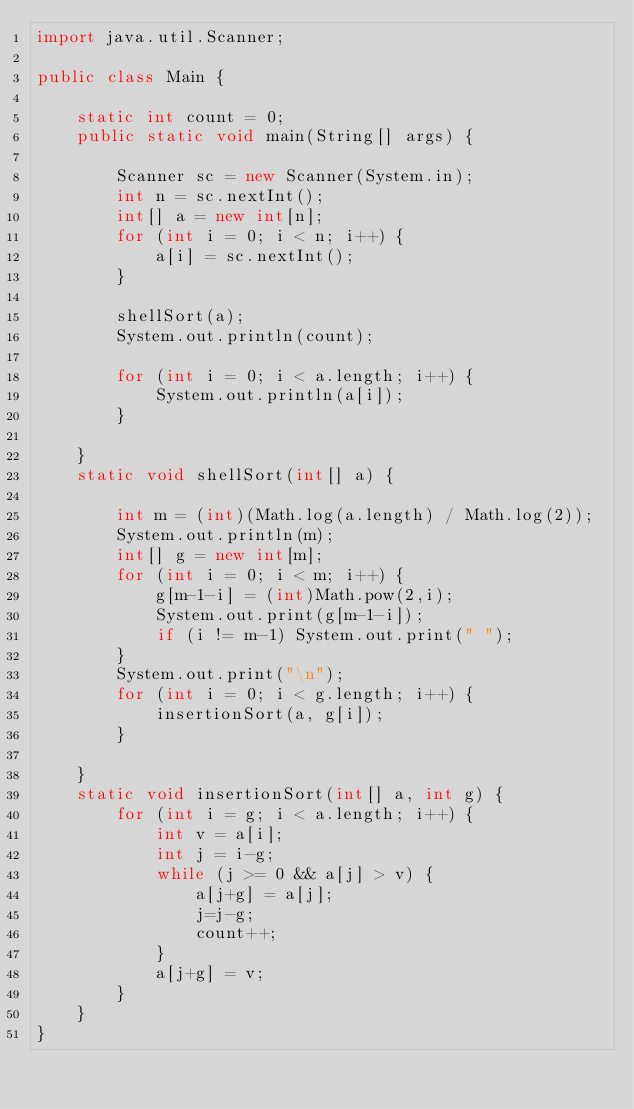<code> <loc_0><loc_0><loc_500><loc_500><_Java_>import java.util.Scanner;

public class Main {

	static int count = 0;
	public static void main(String[] args) {

		Scanner sc = new Scanner(System.in);
		int n = sc.nextInt();
		int[] a = new int[n];
		for (int i = 0; i < n; i++) {
			a[i] = sc.nextInt();
		}

		shellSort(a);
		System.out.println(count);

		for (int i = 0; i < a.length; i++) {
			System.out.println(a[i]);
		}

	}
	static void shellSort(int[] a) {

		int m = (int)(Math.log(a.length) / Math.log(2));
		System.out.println(m);
		int[] g = new int[m];
		for (int i = 0; i < m; i++) {
			g[m-1-i] = (int)Math.pow(2,i);
			System.out.print(g[m-1-i]);
			if (i != m-1) System.out.print(" ");
		}
		System.out.print("\n");
		for (int i = 0; i < g.length; i++) {
			insertionSort(a, g[i]);
		}

	}
	static void insertionSort(int[] a, int g) {
		for (int i = g; i < a.length; i++) {
			int v = a[i];
			int j = i-g;
			while (j >= 0 && a[j] > v) {
				a[j+g] = a[j];
				j=j-g;
				count++;
			}
			a[j+g] = v;
		}
	}
}

</code> 